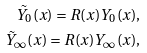<formula> <loc_0><loc_0><loc_500><loc_500>\tilde { Y } _ { 0 } ( x ) = R ( x ) Y _ { 0 } ( x ) , \\ \tilde { Y } _ { \infty } ( x ) = R ( x ) Y _ { \infty } ( x ) ,</formula> 